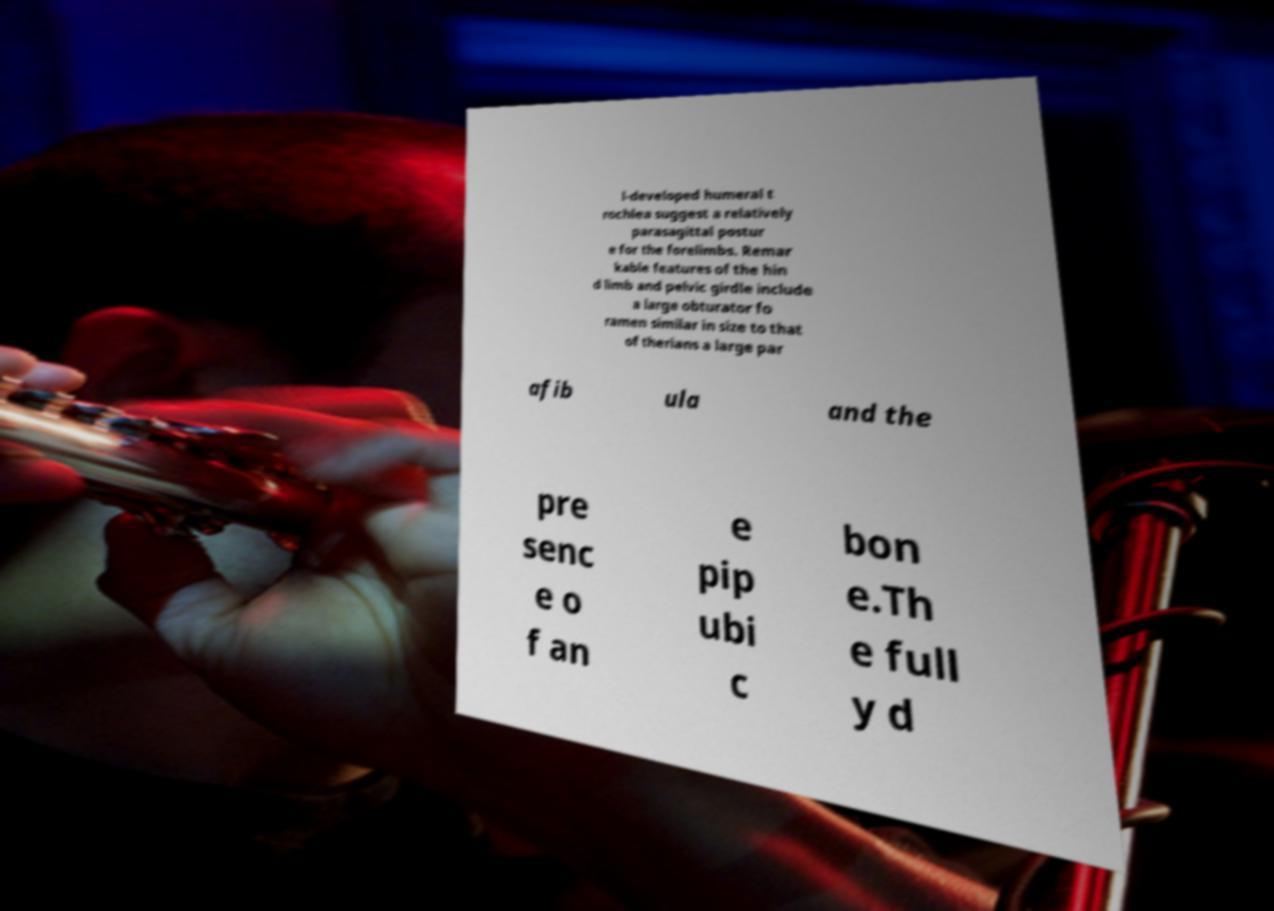For documentation purposes, I need the text within this image transcribed. Could you provide that? l-developed humeral t rochlea suggest a relatively parasagittal postur e for the forelimbs. Remar kable features of the hin d limb and pelvic girdle include a large obturator fo ramen similar in size to that of therians a large par afib ula and the pre senc e o f an e pip ubi c bon e.Th e full y d 